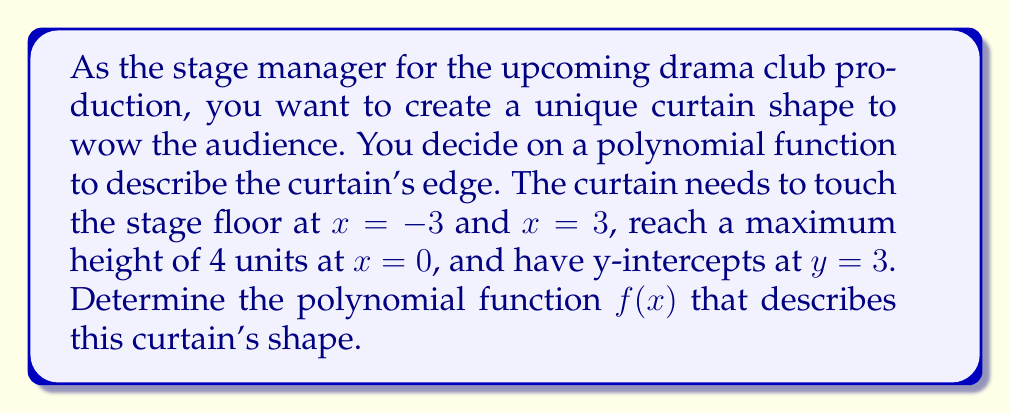Help me with this question. Let's approach this step-by-step:

1) We know the polynomial passes through (-3,0), (3,0), and (0,4), and has y-intercepts at y = 3. This suggests a 4th degree polynomial.

2) The general form of a 4th degree polynomial is:
   $f(x) = ax^4 + bx^2 + c$
   (We can omit $x^3$ and $x$ terms due to symmetry around the y-axis)

3) Using the given points:
   $f(-3) = 0$: $81a + 9b + c = 0$ ... (1)
   $f(3) = 0$: $81a + 9b + c = 0$ ... (2)
   $f(0) = 4$: $c = 4$ ... (3)

4) From (3), we know $c = 4$. Substituting this into (1) or (2):
   $81a + 9b = -4$ ... (4)

5) We're also told that $f(x)$ has y-intercepts at y = 3. This means:
   $f(x) - 3 = a(x^2 - 3)(x^2 + 3)$
   $ax^4 + bx^2 + 1 = a(x^4 - 9)$

6) Comparing coefficients:
   $b = -9a$ ... (5)

7) Substituting (5) into (4):
   $81a - 81a = -4$
   $a = \frac{1}{20}$

8) From (5), we can now find $b$:
   $b = -9(\frac{1}{20}) = -\frac{9}{20}$

Therefore, the polynomial function is:
$f(x) = \frac{1}{20}x^4 - \frac{9}{20}x^2 + 4$
Answer: $f(x) = \frac{1}{20}x^4 - \frac{9}{20}x^2 + 4$ 